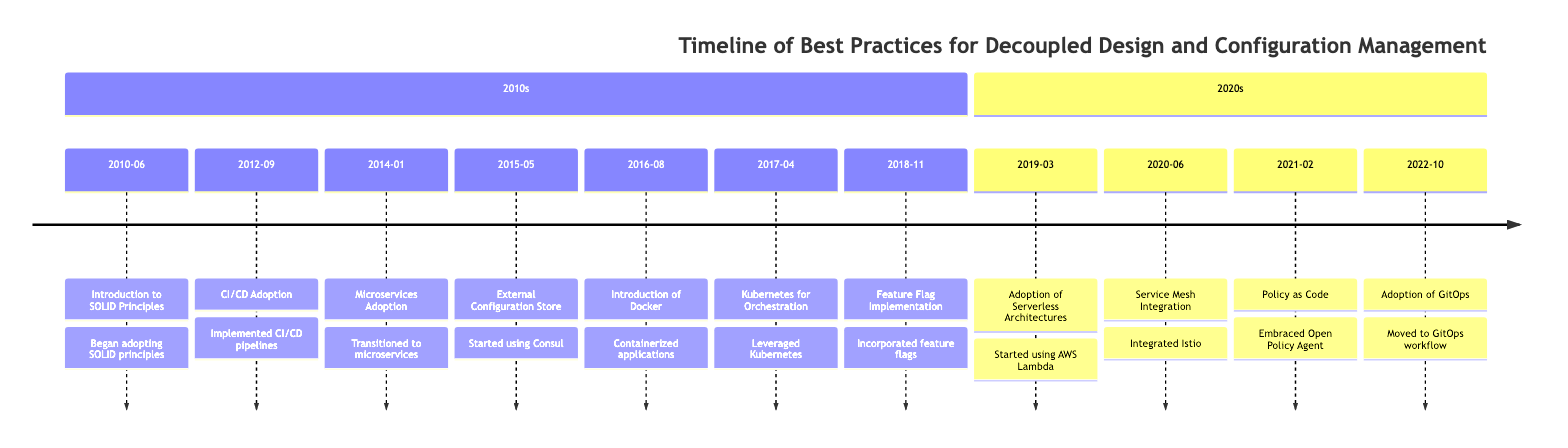What event occurred in 2015? In 2015, the event listed in the timeline is "External Configuration Store". This date is specifically shown with its corresponding event title, confirming it as the event for that year.
Answer: External Configuration Store How many events occurred in the 2010s? There are seven events listed under the 2010s section of the timeline. This includes the events from June 2010 to November 2018. Counting them gives a total of seven distinct events.
Answer: 7 Which practice was adopted immediately after Docker? The event that follows the introduction of Docker in August 2016 is "Kubernetes for Orchestration", which is listed directly after it in the timeline.
Answer: Kubernetes for Orchestration What significant change was made in 2014? The significant change made in 2014 was the "Microservices Adoption", indicating the transition to a microservices architecture which is a key move towards decoupling.
Answer: Microservices Adoption What was the last event in the timeline? The last event listed in the timeline is from October 2022 and is "Adoption of GitOps". It is the final entry, thus confirming its position as the last event.
Answer: Adoption of GitOps Name the technology introduced in 2019. The technology introduced in 2019 is "AWS Lambda", marking the adoption of serverless architectures that further enhance decoupling strategies.
Answer: AWS Lambda Which event came before the integration of Istio? The event that came before the integration of Istio in June 2020 was "Adoption of Serverless Architectures" which occurred in March 2019. This shows a sequence in adopting newer technologies.
Answer: Adoption of Serverless Architectures How was configuration management handled starting in 2015? Starting in 2015, configuration management was handled by using "Consul", which facilitated centralized management while avoiding the use of reflection for accessing settings.
Answer: Consul What do the events from 2020 to 2022 emphasize? The events from 2020 to 2022 emphasize advanced integration and management of configurations, specifically through practices like “Service Mesh Integration”, “Policy as Code”, and “Adoption of GitOps” which signify a trend toward automation and policy management.
Answer: Advanced integration and management of configurations 